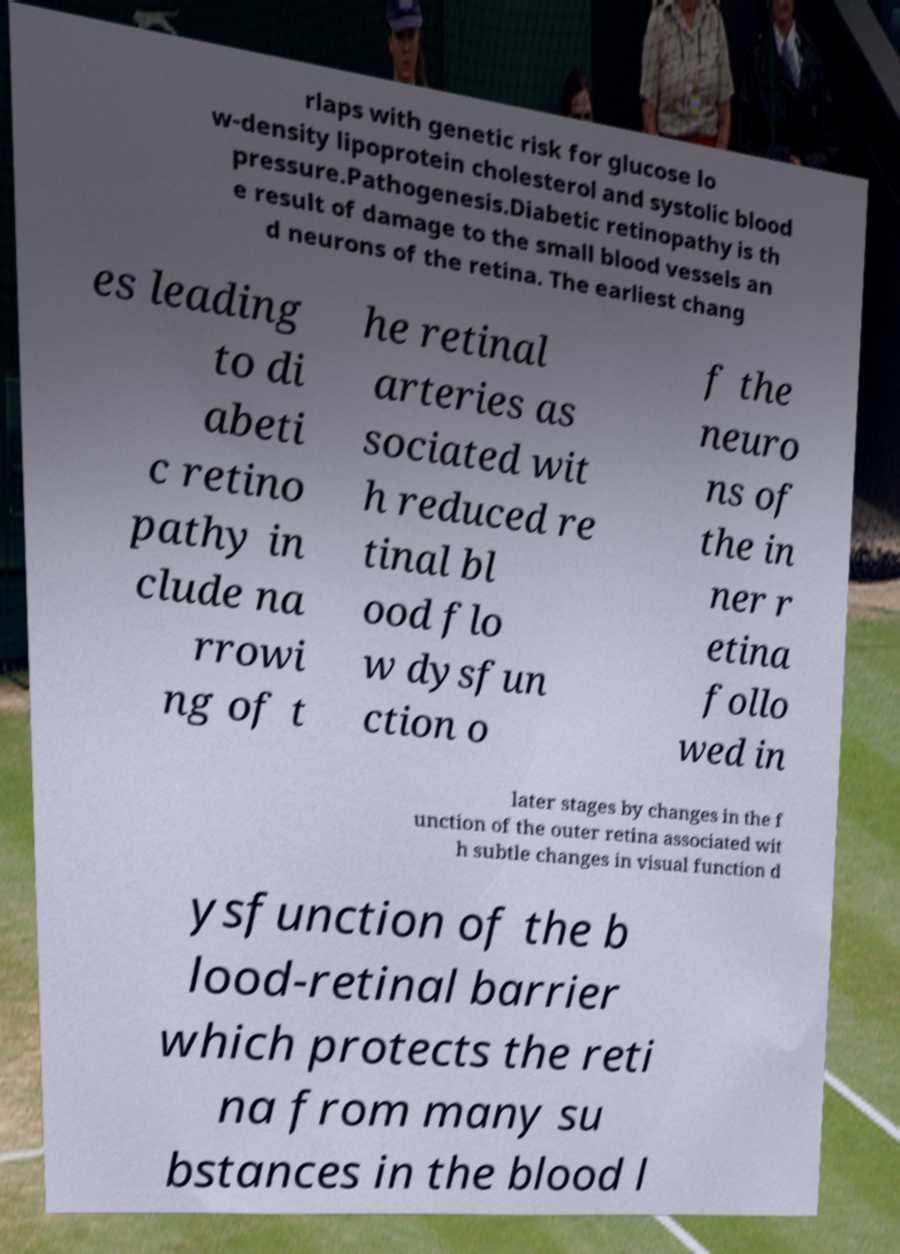Can you accurately transcribe the text from the provided image for me? rlaps with genetic risk for glucose lo w-density lipoprotein cholesterol and systolic blood pressure.Pathogenesis.Diabetic retinopathy is th e result of damage to the small blood vessels an d neurons of the retina. The earliest chang es leading to di abeti c retino pathy in clude na rrowi ng of t he retinal arteries as sociated wit h reduced re tinal bl ood flo w dysfun ction o f the neuro ns of the in ner r etina follo wed in later stages by changes in the f unction of the outer retina associated wit h subtle changes in visual function d ysfunction of the b lood-retinal barrier which protects the reti na from many su bstances in the blood l 